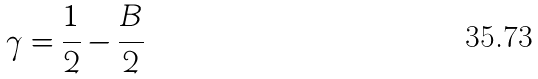<formula> <loc_0><loc_0><loc_500><loc_500>\gamma = \frac { 1 } { 2 } - \frac { B } { 2 }</formula> 